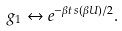Convert formula to latex. <formula><loc_0><loc_0><loc_500><loc_500>g _ { 1 } \leftrightarrow e ^ { - \beta t \, s ( \beta U ) / 2 } .</formula> 